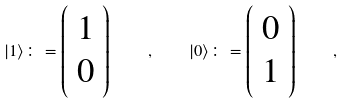Convert formula to latex. <formula><loc_0><loc_0><loc_500><loc_500>| 1 \rangle \colon = \left ( \begin{array} { c } 1 \\ 0 \\ \end{array} \right ) \quad , \quad | 0 \rangle \colon = \left ( \begin{array} { c } 0 \\ 1 \\ \end{array} \right ) \quad ,</formula> 